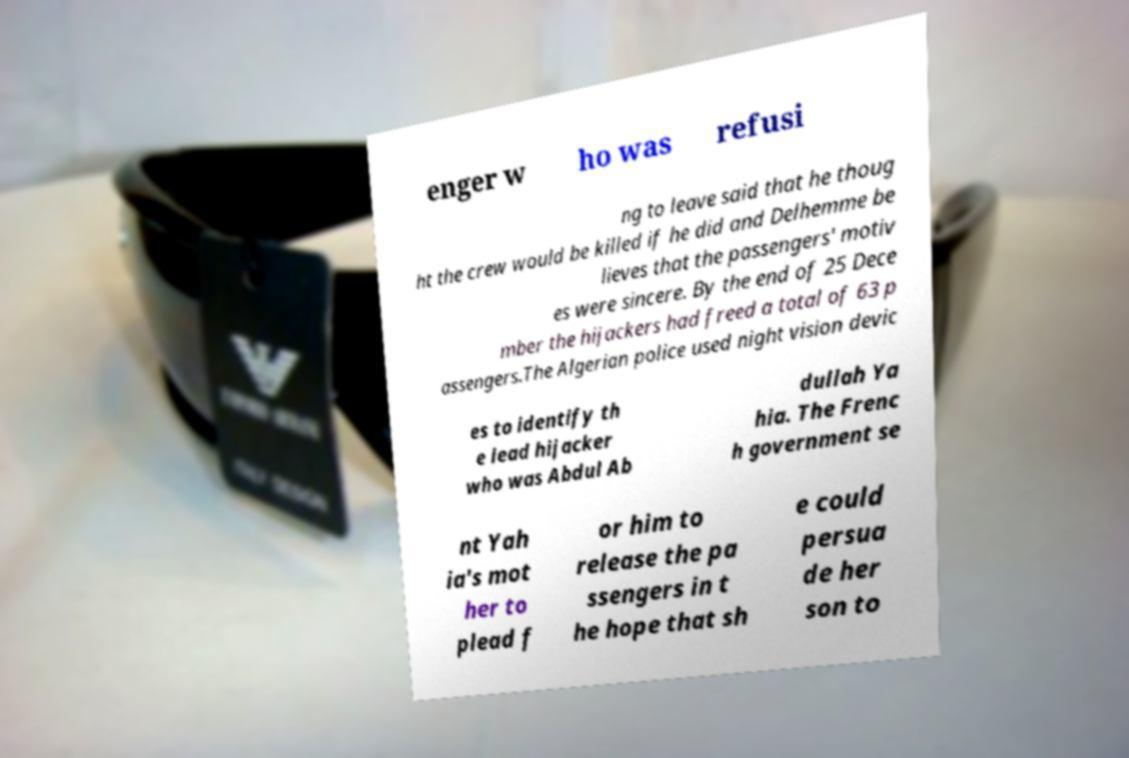Can you accurately transcribe the text from the provided image for me? enger w ho was refusi ng to leave said that he thoug ht the crew would be killed if he did and Delhemme be lieves that the passengers' motiv es were sincere. By the end of 25 Dece mber the hijackers had freed a total of 63 p assengers.The Algerian police used night vision devic es to identify th e lead hijacker who was Abdul Ab dullah Ya hia. The Frenc h government se nt Yah ia's mot her to plead f or him to release the pa ssengers in t he hope that sh e could persua de her son to 